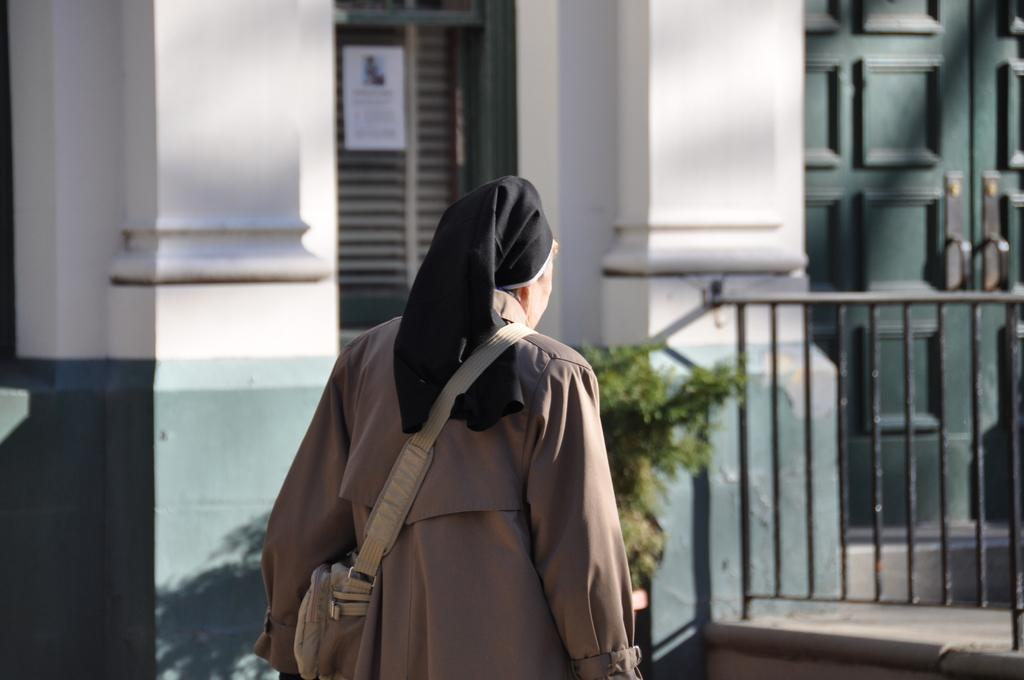Who is present in the image? There is a woman in the image. What is the woman wearing? The woman is wearing a brown dress. What is the woman carrying in the image? The woman is carrying a bag. What type of structure can be seen in the image? There is a building in the image. What type of vegetation is present in the image? There is a plant in the image. What type of lock is the fireman using to secure the building in the image? There is no fireman or lock present in the image. What type of spoon is the woman using to eat her meal in the image? There is no spoon visible in the image; the woman is carrying a bag. 